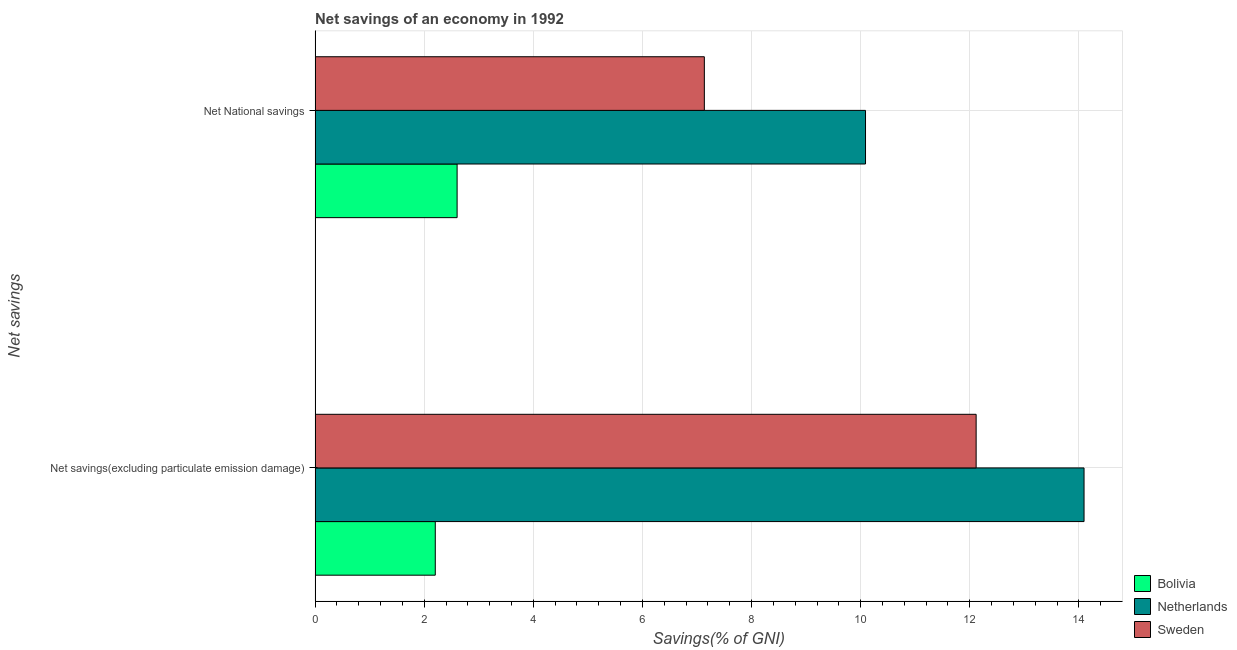Are the number of bars per tick equal to the number of legend labels?
Provide a succinct answer. Yes. How many bars are there on the 1st tick from the bottom?
Your answer should be very brief. 3. What is the label of the 1st group of bars from the top?
Your response must be concise. Net National savings. What is the net national savings in Bolivia?
Give a very brief answer. 2.6. Across all countries, what is the maximum net savings(excluding particulate emission damage)?
Offer a very short reply. 14.09. Across all countries, what is the minimum net national savings?
Your answer should be compact. 2.6. What is the total net national savings in the graph?
Provide a short and direct response. 19.83. What is the difference between the net savings(excluding particulate emission damage) in Sweden and that in Bolivia?
Make the answer very short. 9.91. What is the difference between the net savings(excluding particulate emission damage) in Sweden and the net national savings in Netherlands?
Offer a terse response. 2.03. What is the average net national savings per country?
Your answer should be very brief. 6.61. What is the difference between the net national savings and net savings(excluding particulate emission damage) in Netherlands?
Your answer should be very brief. -4.01. What is the ratio of the net national savings in Netherlands to that in Sweden?
Make the answer very short. 1.41. In how many countries, is the net savings(excluding particulate emission damage) greater than the average net savings(excluding particulate emission damage) taken over all countries?
Provide a succinct answer. 2. How many bars are there?
Give a very brief answer. 6. Are all the bars in the graph horizontal?
Offer a very short reply. Yes. How many countries are there in the graph?
Your answer should be very brief. 3. What is the difference between two consecutive major ticks on the X-axis?
Your response must be concise. 2. Are the values on the major ticks of X-axis written in scientific E-notation?
Provide a succinct answer. No. Does the graph contain any zero values?
Keep it short and to the point. No. Does the graph contain grids?
Your response must be concise. Yes. What is the title of the graph?
Provide a short and direct response. Net savings of an economy in 1992. Does "Albania" appear as one of the legend labels in the graph?
Keep it short and to the point. No. What is the label or title of the X-axis?
Your answer should be very brief. Savings(% of GNI). What is the label or title of the Y-axis?
Offer a terse response. Net savings. What is the Savings(% of GNI) in Bolivia in Net savings(excluding particulate emission damage)?
Your response must be concise. 2.2. What is the Savings(% of GNI) of Netherlands in Net savings(excluding particulate emission damage)?
Give a very brief answer. 14.09. What is the Savings(% of GNI) of Sweden in Net savings(excluding particulate emission damage)?
Offer a very short reply. 12.12. What is the Savings(% of GNI) of Bolivia in Net National savings?
Provide a succinct answer. 2.6. What is the Savings(% of GNI) in Netherlands in Net National savings?
Provide a succinct answer. 10.09. What is the Savings(% of GNI) in Sweden in Net National savings?
Make the answer very short. 7.13. Across all Net savings, what is the maximum Savings(% of GNI) of Bolivia?
Provide a succinct answer. 2.6. Across all Net savings, what is the maximum Savings(% of GNI) in Netherlands?
Make the answer very short. 14.09. Across all Net savings, what is the maximum Savings(% of GNI) of Sweden?
Make the answer very short. 12.12. Across all Net savings, what is the minimum Savings(% of GNI) of Bolivia?
Offer a terse response. 2.2. Across all Net savings, what is the minimum Savings(% of GNI) in Netherlands?
Give a very brief answer. 10.09. Across all Net savings, what is the minimum Savings(% of GNI) of Sweden?
Offer a very short reply. 7.13. What is the total Savings(% of GNI) of Bolivia in the graph?
Offer a very short reply. 4.81. What is the total Savings(% of GNI) in Netherlands in the graph?
Give a very brief answer. 24.18. What is the total Savings(% of GNI) of Sweden in the graph?
Your response must be concise. 19.25. What is the difference between the Savings(% of GNI) of Bolivia in Net savings(excluding particulate emission damage) and that in Net National savings?
Keep it short and to the point. -0.4. What is the difference between the Savings(% of GNI) of Netherlands in Net savings(excluding particulate emission damage) and that in Net National savings?
Your answer should be very brief. 4.01. What is the difference between the Savings(% of GNI) in Sweden in Net savings(excluding particulate emission damage) and that in Net National savings?
Your answer should be very brief. 4.98. What is the difference between the Savings(% of GNI) in Bolivia in Net savings(excluding particulate emission damage) and the Savings(% of GNI) in Netherlands in Net National savings?
Your answer should be compact. -7.89. What is the difference between the Savings(% of GNI) in Bolivia in Net savings(excluding particulate emission damage) and the Savings(% of GNI) in Sweden in Net National savings?
Your answer should be very brief. -4.93. What is the difference between the Savings(% of GNI) in Netherlands in Net savings(excluding particulate emission damage) and the Savings(% of GNI) in Sweden in Net National savings?
Offer a terse response. 6.96. What is the average Savings(% of GNI) in Bolivia per Net savings?
Provide a succinct answer. 2.4. What is the average Savings(% of GNI) of Netherlands per Net savings?
Provide a succinct answer. 12.09. What is the average Savings(% of GNI) of Sweden per Net savings?
Offer a terse response. 9.63. What is the difference between the Savings(% of GNI) in Bolivia and Savings(% of GNI) in Netherlands in Net savings(excluding particulate emission damage)?
Give a very brief answer. -11.89. What is the difference between the Savings(% of GNI) in Bolivia and Savings(% of GNI) in Sweden in Net savings(excluding particulate emission damage)?
Provide a succinct answer. -9.91. What is the difference between the Savings(% of GNI) of Netherlands and Savings(% of GNI) of Sweden in Net savings(excluding particulate emission damage)?
Provide a short and direct response. 1.98. What is the difference between the Savings(% of GNI) in Bolivia and Savings(% of GNI) in Netherlands in Net National savings?
Offer a terse response. -7.49. What is the difference between the Savings(% of GNI) in Bolivia and Savings(% of GNI) in Sweden in Net National savings?
Keep it short and to the point. -4.53. What is the difference between the Savings(% of GNI) in Netherlands and Savings(% of GNI) in Sweden in Net National savings?
Give a very brief answer. 2.95. What is the ratio of the Savings(% of GNI) of Bolivia in Net savings(excluding particulate emission damage) to that in Net National savings?
Offer a very short reply. 0.85. What is the ratio of the Savings(% of GNI) in Netherlands in Net savings(excluding particulate emission damage) to that in Net National savings?
Make the answer very short. 1.4. What is the ratio of the Savings(% of GNI) in Sweden in Net savings(excluding particulate emission damage) to that in Net National savings?
Ensure brevity in your answer.  1.7. What is the difference between the highest and the second highest Savings(% of GNI) in Bolivia?
Your answer should be very brief. 0.4. What is the difference between the highest and the second highest Savings(% of GNI) in Netherlands?
Offer a very short reply. 4.01. What is the difference between the highest and the second highest Savings(% of GNI) of Sweden?
Offer a terse response. 4.98. What is the difference between the highest and the lowest Savings(% of GNI) of Bolivia?
Provide a short and direct response. 0.4. What is the difference between the highest and the lowest Savings(% of GNI) in Netherlands?
Offer a terse response. 4.01. What is the difference between the highest and the lowest Savings(% of GNI) in Sweden?
Ensure brevity in your answer.  4.98. 